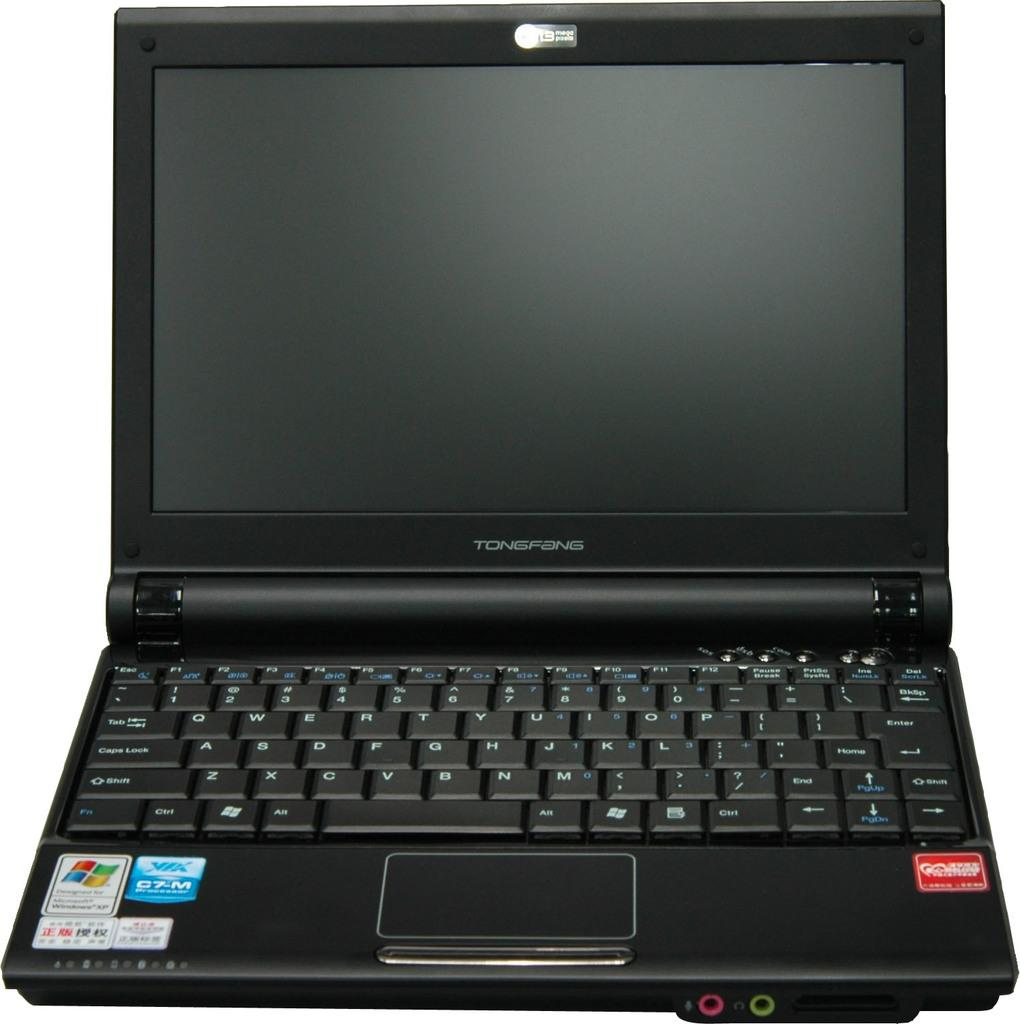<image>
Give a short and clear explanation of the subsequent image. A Tongfang laptop computer is open but shut off. 